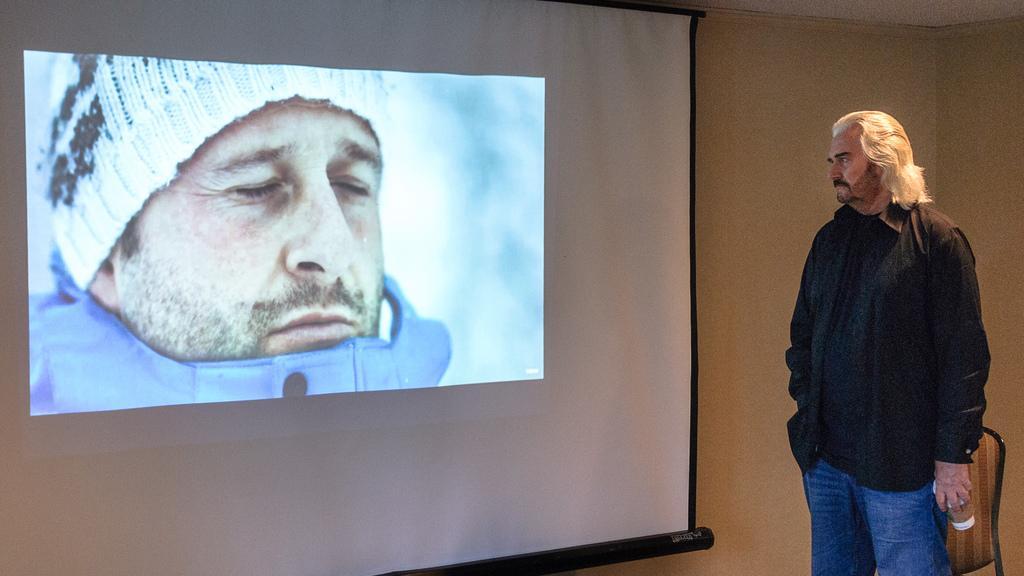Please provide a concise description of this image. In this image there is a man on the right side who is holding the coffee cup, Beside him there is a chair. In the middle there is a screen. In the screen we can see that there is a man who is wearing the cap. In the background there is a wall. 